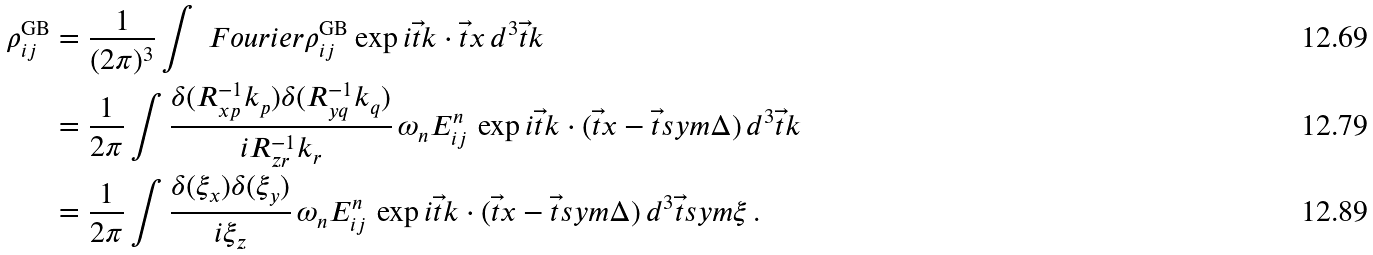<formula> <loc_0><loc_0><loc_500><loc_500>\rho ^ { \text {GB} } _ { i j } & = \frac { 1 } { ( 2 \pi ) ^ { 3 } } \int \ F o u r i e r { \rho } ^ { \text {GB} } _ { i j } \exp { i \vec { t } { k } \cdot \vec { t } { x } } \, d ^ { 3 } \vec { t } { k } \\ & = \frac { 1 } { 2 \pi } \int \frac { \delta ( R ^ { - 1 } _ { x p } k _ { p } ) \delta ( R ^ { - 1 } _ { y q } k _ { q } ) } { i R ^ { - 1 } _ { z r } k _ { r } } \, \omega _ { n } E ^ { n } _ { i j } \, \exp { i \vec { t } { k } \cdot ( \vec { t } { x } - \vec { t } s y m { \Delta } ) } \, d ^ { 3 } \vec { t } { k } \\ & = \frac { 1 } { 2 \pi } \int \frac { \delta ( \xi _ { x } ) \delta ( \xi _ { y } ) } { i \xi _ { z } } \, \omega _ { n } E ^ { n } _ { i j } \, \exp { i \vec { t } { k } \cdot ( \vec { t } { x } - \vec { t } s y m { \Delta } ) } \, d ^ { 3 } \vec { t } s y m { \xi } \, .</formula> 